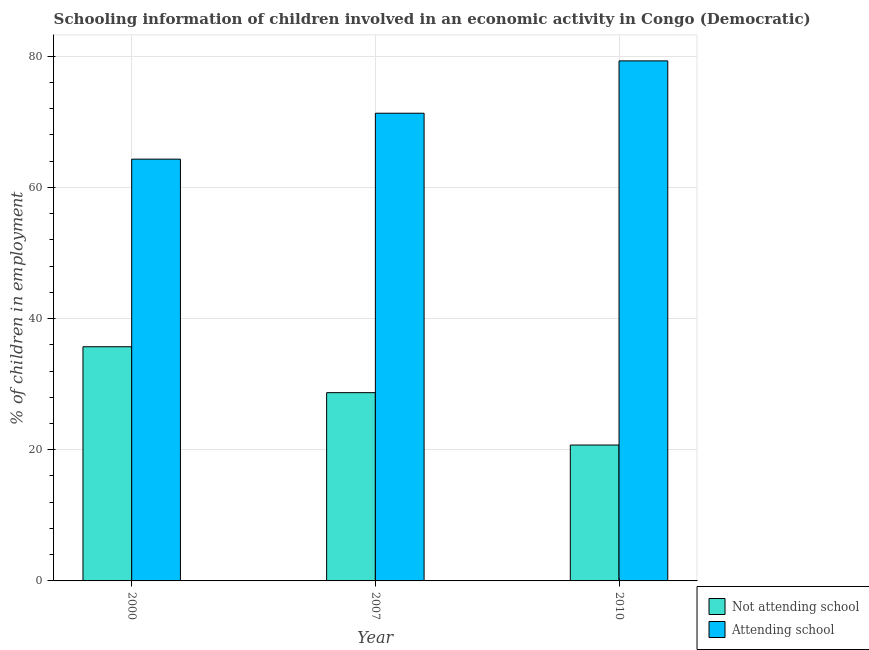Are the number of bars on each tick of the X-axis equal?
Offer a terse response. Yes. What is the label of the 1st group of bars from the left?
Keep it short and to the point. 2000. What is the percentage of employed children who are attending school in 2007?
Give a very brief answer. 71.3. Across all years, what is the maximum percentage of employed children who are attending school?
Your answer should be compact. 79.28. Across all years, what is the minimum percentage of employed children who are attending school?
Your answer should be compact. 64.3. In which year was the percentage of employed children who are not attending school maximum?
Your answer should be very brief. 2000. What is the total percentage of employed children who are not attending school in the graph?
Offer a terse response. 85.12. What is the difference between the percentage of employed children who are attending school in 2000 and that in 2007?
Offer a terse response. -7. What is the average percentage of employed children who are not attending school per year?
Provide a short and direct response. 28.37. In the year 2007, what is the difference between the percentage of employed children who are not attending school and percentage of employed children who are attending school?
Give a very brief answer. 0. In how many years, is the percentage of employed children who are attending school greater than 72 %?
Provide a succinct answer. 1. What is the ratio of the percentage of employed children who are attending school in 2007 to that in 2010?
Your response must be concise. 0.9. Is the percentage of employed children who are attending school in 2007 less than that in 2010?
Offer a terse response. Yes. Is the difference between the percentage of employed children who are attending school in 2007 and 2010 greater than the difference between the percentage of employed children who are not attending school in 2007 and 2010?
Ensure brevity in your answer.  No. What is the difference between the highest and the second highest percentage of employed children who are attending school?
Ensure brevity in your answer.  7.98. What is the difference between the highest and the lowest percentage of employed children who are not attending school?
Keep it short and to the point. 14.98. What does the 1st bar from the left in 2010 represents?
Offer a terse response. Not attending school. What does the 2nd bar from the right in 2010 represents?
Make the answer very short. Not attending school. How many bars are there?
Your answer should be compact. 6. Are all the bars in the graph horizontal?
Your response must be concise. No. Does the graph contain grids?
Give a very brief answer. Yes. Where does the legend appear in the graph?
Provide a succinct answer. Bottom right. How are the legend labels stacked?
Provide a succinct answer. Vertical. What is the title of the graph?
Offer a very short reply. Schooling information of children involved in an economic activity in Congo (Democratic). What is the label or title of the Y-axis?
Ensure brevity in your answer.  % of children in employment. What is the % of children in employment of Not attending school in 2000?
Offer a terse response. 35.7. What is the % of children in employment in Attending school in 2000?
Offer a terse response. 64.3. What is the % of children in employment in Not attending school in 2007?
Make the answer very short. 28.7. What is the % of children in employment in Attending school in 2007?
Offer a terse response. 71.3. What is the % of children in employment in Not attending school in 2010?
Give a very brief answer. 20.72. What is the % of children in employment of Attending school in 2010?
Offer a very short reply. 79.28. Across all years, what is the maximum % of children in employment in Not attending school?
Your answer should be very brief. 35.7. Across all years, what is the maximum % of children in employment in Attending school?
Offer a terse response. 79.28. Across all years, what is the minimum % of children in employment of Not attending school?
Offer a terse response. 20.72. Across all years, what is the minimum % of children in employment in Attending school?
Provide a succinct answer. 64.3. What is the total % of children in employment of Not attending school in the graph?
Ensure brevity in your answer.  85.12. What is the total % of children in employment of Attending school in the graph?
Provide a succinct answer. 214.88. What is the difference between the % of children in employment of Attending school in 2000 and that in 2007?
Offer a terse response. -7. What is the difference between the % of children in employment of Not attending school in 2000 and that in 2010?
Offer a very short reply. 14.98. What is the difference between the % of children in employment in Attending school in 2000 and that in 2010?
Your response must be concise. -14.98. What is the difference between the % of children in employment in Not attending school in 2007 and that in 2010?
Your response must be concise. 7.98. What is the difference between the % of children in employment of Attending school in 2007 and that in 2010?
Give a very brief answer. -7.98. What is the difference between the % of children in employment of Not attending school in 2000 and the % of children in employment of Attending school in 2007?
Your answer should be very brief. -35.6. What is the difference between the % of children in employment of Not attending school in 2000 and the % of children in employment of Attending school in 2010?
Your response must be concise. -43.58. What is the difference between the % of children in employment of Not attending school in 2007 and the % of children in employment of Attending school in 2010?
Make the answer very short. -50.58. What is the average % of children in employment in Not attending school per year?
Your answer should be very brief. 28.37. What is the average % of children in employment in Attending school per year?
Offer a terse response. 71.63. In the year 2000, what is the difference between the % of children in employment in Not attending school and % of children in employment in Attending school?
Your response must be concise. -28.6. In the year 2007, what is the difference between the % of children in employment of Not attending school and % of children in employment of Attending school?
Provide a succinct answer. -42.6. In the year 2010, what is the difference between the % of children in employment of Not attending school and % of children in employment of Attending school?
Offer a very short reply. -58.56. What is the ratio of the % of children in employment in Not attending school in 2000 to that in 2007?
Keep it short and to the point. 1.24. What is the ratio of the % of children in employment of Attending school in 2000 to that in 2007?
Your answer should be compact. 0.9. What is the ratio of the % of children in employment of Not attending school in 2000 to that in 2010?
Give a very brief answer. 1.72. What is the ratio of the % of children in employment of Attending school in 2000 to that in 2010?
Your answer should be very brief. 0.81. What is the ratio of the % of children in employment of Not attending school in 2007 to that in 2010?
Your response must be concise. 1.39. What is the ratio of the % of children in employment of Attending school in 2007 to that in 2010?
Keep it short and to the point. 0.9. What is the difference between the highest and the second highest % of children in employment in Attending school?
Your answer should be compact. 7.98. What is the difference between the highest and the lowest % of children in employment of Not attending school?
Provide a short and direct response. 14.98. What is the difference between the highest and the lowest % of children in employment of Attending school?
Provide a succinct answer. 14.98. 